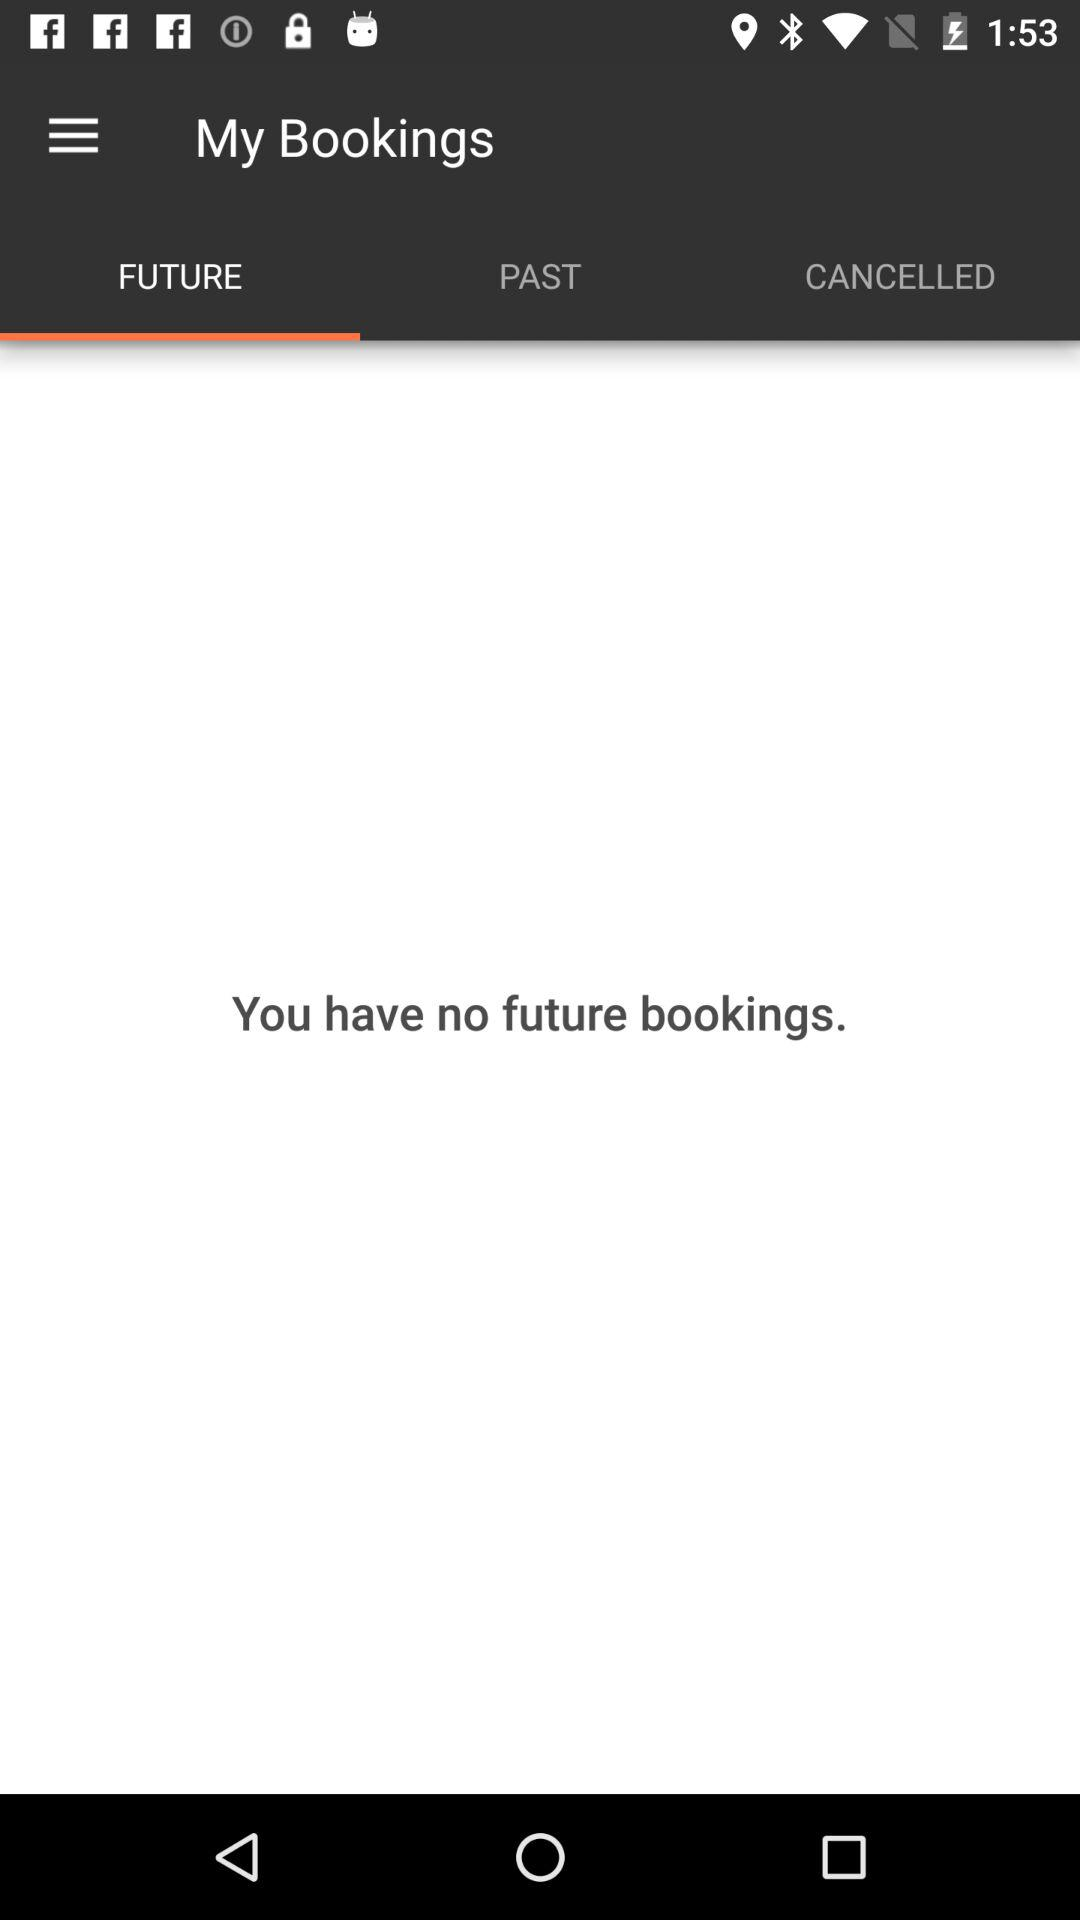What is the selected tab? The selected tab is "FUTURE". 